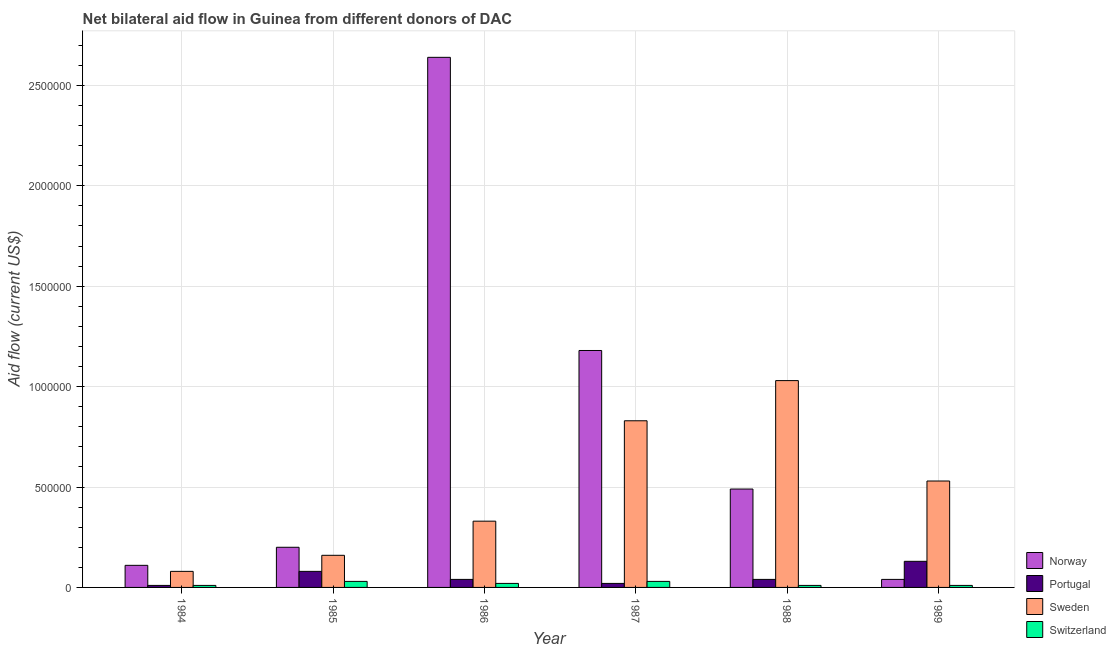How many groups of bars are there?
Your response must be concise. 6. Are the number of bars per tick equal to the number of legend labels?
Your answer should be compact. Yes. Are the number of bars on each tick of the X-axis equal?
Your response must be concise. Yes. How many bars are there on the 6th tick from the right?
Provide a short and direct response. 4. What is the label of the 1st group of bars from the left?
Make the answer very short. 1984. In how many cases, is the number of bars for a given year not equal to the number of legend labels?
Keep it short and to the point. 0. What is the amount of aid given by norway in 1984?
Your answer should be compact. 1.10e+05. Across all years, what is the maximum amount of aid given by portugal?
Make the answer very short. 1.30e+05. Across all years, what is the minimum amount of aid given by sweden?
Provide a short and direct response. 8.00e+04. What is the total amount of aid given by portugal in the graph?
Provide a short and direct response. 3.20e+05. What is the difference between the amount of aid given by sweden in 1985 and that in 1988?
Provide a short and direct response. -8.70e+05. What is the difference between the amount of aid given by portugal in 1984 and the amount of aid given by norway in 1987?
Offer a very short reply. -10000. What is the average amount of aid given by norway per year?
Your answer should be very brief. 7.77e+05. In the year 1988, what is the difference between the amount of aid given by switzerland and amount of aid given by sweden?
Keep it short and to the point. 0. What is the ratio of the amount of aid given by norway in 1984 to that in 1989?
Provide a short and direct response. 2.75. What is the difference between the highest and the second highest amount of aid given by norway?
Make the answer very short. 1.46e+06. What is the difference between the highest and the lowest amount of aid given by switzerland?
Your answer should be compact. 2.00e+04. What does the 3rd bar from the left in 1988 represents?
Make the answer very short. Sweden. What does the 2nd bar from the right in 1984 represents?
Your answer should be compact. Sweden. How many years are there in the graph?
Your answer should be very brief. 6. What is the difference between two consecutive major ticks on the Y-axis?
Your answer should be compact. 5.00e+05. Are the values on the major ticks of Y-axis written in scientific E-notation?
Offer a very short reply. No. Does the graph contain any zero values?
Your response must be concise. No. How many legend labels are there?
Offer a terse response. 4. How are the legend labels stacked?
Your answer should be compact. Vertical. What is the title of the graph?
Your answer should be very brief. Net bilateral aid flow in Guinea from different donors of DAC. What is the label or title of the X-axis?
Make the answer very short. Year. What is the Aid flow (current US$) of Norway in 1984?
Provide a succinct answer. 1.10e+05. What is the Aid flow (current US$) in Norway in 1985?
Make the answer very short. 2.00e+05. What is the Aid flow (current US$) in Switzerland in 1985?
Keep it short and to the point. 3.00e+04. What is the Aid flow (current US$) in Norway in 1986?
Provide a succinct answer. 2.64e+06. What is the Aid flow (current US$) in Portugal in 1986?
Give a very brief answer. 4.00e+04. What is the Aid flow (current US$) in Switzerland in 1986?
Make the answer very short. 2.00e+04. What is the Aid flow (current US$) of Norway in 1987?
Ensure brevity in your answer.  1.18e+06. What is the Aid flow (current US$) of Sweden in 1987?
Your response must be concise. 8.30e+05. What is the Aid flow (current US$) of Norway in 1988?
Provide a short and direct response. 4.90e+05. What is the Aid flow (current US$) of Portugal in 1988?
Make the answer very short. 4.00e+04. What is the Aid flow (current US$) in Sweden in 1988?
Make the answer very short. 1.03e+06. What is the Aid flow (current US$) in Sweden in 1989?
Your answer should be compact. 5.30e+05. Across all years, what is the maximum Aid flow (current US$) in Norway?
Offer a terse response. 2.64e+06. Across all years, what is the maximum Aid flow (current US$) in Sweden?
Your response must be concise. 1.03e+06. What is the total Aid flow (current US$) in Norway in the graph?
Offer a terse response. 4.66e+06. What is the total Aid flow (current US$) in Portugal in the graph?
Offer a very short reply. 3.20e+05. What is the total Aid flow (current US$) in Sweden in the graph?
Give a very brief answer. 2.96e+06. What is the difference between the Aid flow (current US$) in Portugal in 1984 and that in 1985?
Provide a succinct answer. -7.00e+04. What is the difference between the Aid flow (current US$) in Sweden in 1984 and that in 1985?
Make the answer very short. -8.00e+04. What is the difference between the Aid flow (current US$) in Switzerland in 1984 and that in 1985?
Make the answer very short. -2.00e+04. What is the difference between the Aid flow (current US$) in Norway in 1984 and that in 1986?
Make the answer very short. -2.53e+06. What is the difference between the Aid flow (current US$) in Portugal in 1984 and that in 1986?
Give a very brief answer. -3.00e+04. What is the difference between the Aid flow (current US$) of Norway in 1984 and that in 1987?
Keep it short and to the point. -1.07e+06. What is the difference between the Aid flow (current US$) in Portugal in 1984 and that in 1987?
Your answer should be very brief. -10000. What is the difference between the Aid flow (current US$) in Sweden in 1984 and that in 1987?
Offer a very short reply. -7.50e+05. What is the difference between the Aid flow (current US$) of Switzerland in 1984 and that in 1987?
Provide a succinct answer. -2.00e+04. What is the difference between the Aid flow (current US$) of Norway in 1984 and that in 1988?
Provide a short and direct response. -3.80e+05. What is the difference between the Aid flow (current US$) in Sweden in 1984 and that in 1988?
Your answer should be very brief. -9.50e+05. What is the difference between the Aid flow (current US$) of Portugal in 1984 and that in 1989?
Make the answer very short. -1.20e+05. What is the difference between the Aid flow (current US$) in Sweden in 1984 and that in 1989?
Offer a very short reply. -4.50e+05. What is the difference between the Aid flow (current US$) of Switzerland in 1984 and that in 1989?
Your answer should be compact. 0. What is the difference between the Aid flow (current US$) of Norway in 1985 and that in 1986?
Make the answer very short. -2.44e+06. What is the difference between the Aid flow (current US$) in Sweden in 1985 and that in 1986?
Give a very brief answer. -1.70e+05. What is the difference between the Aid flow (current US$) in Norway in 1985 and that in 1987?
Your answer should be very brief. -9.80e+05. What is the difference between the Aid flow (current US$) in Portugal in 1985 and that in 1987?
Your response must be concise. 6.00e+04. What is the difference between the Aid flow (current US$) of Sweden in 1985 and that in 1987?
Make the answer very short. -6.70e+05. What is the difference between the Aid flow (current US$) in Portugal in 1985 and that in 1988?
Provide a short and direct response. 4.00e+04. What is the difference between the Aid flow (current US$) of Sweden in 1985 and that in 1988?
Your answer should be compact. -8.70e+05. What is the difference between the Aid flow (current US$) in Norway in 1985 and that in 1989?
Provide a succinct answer. 1.60e+05. What is the difference between the Aid flow (current US$) of Portugal in 1985 and that in 1989?
Offer a very short reply. -5.00e+04. What is the difference between the Aid flow (current US$) in Sweden in 1985 and that in 1989?
Provide a short and direct response. -3.70e+05. What is the difference between the Aid flow (current US$) in Norway in 1986 and that in 1987?
Offer a terse response. 1.46e+06. What is the difference between the Aid flow (current US$) of Sweden in 1986 and that in 1987?
Give a very brief answer. -5.00e+05. What is the difference between the Aid flow (current US$) in Norway in 1986 and that in 1988?
Your answer should be compact. 2.15e+06. What is the difference between the Aid flow (current US$) of Sweden in 1986 and that in 1988?
Your answer should be very brief. -7.00e+05. What is the difference between the Aid flow (current US$) in Switzerland in 1986 and that in 1988?
Your answer should be compact. 10000. What is the difference between the Aid flow (current US$) in Norway in 1986 and that in 1989?
Offer a very short reply. 2.60e+06. What is the difference between the Aid flow (current US$) of Portugal in 1986 and that in 1989?
Give a very brief answer. -9.00e+04. What is the difference between the Aid flow (current US$) in Sweden in 1986 and that in 1989?
Your answer should be very brief. -2.00e+05. What is the difference between the Aid flow (current US$) in Switzerland in 1986 and that in 1989?
Your answer should be compact. 10000. What is the difference between the Aid flow (current US$) in Norway in 1987 and that in 1988?
Offer a terse response. 6.90e+05. What is the difference between the Aid flow (current US$) in Portugal in 1987 and that in 1988?
Your answer should be compact. -2.00e+04. What is the difference between the Aid flow (current US$) in Norway in 1987 and that in 1989?
Provide a succinct answer. 1.14e+06. What is the difference between the Aid flow (current US$) of Sweden in 1988 and that in 1989?
Ensure brevity in your answer.  5.00e+05. What is the difference between the Aid flow (current US$) of Norway in 1984 and the Aid flow (current US$) of Portugal in 1985?
Your response must be concise. 3.00e+04. What is the difference between the Aid flow (current US$) of Norway in 1984 and the Aid flow (current US$) of Sweden in 1985?
Provide a short and direct response. -5.00e+04. What is the difference between the Aid flow (current US$) of Portugal in 1984 and the Aid flow (current US$) of Sweden in 1985?
Provide a succinct answer. -1.50e+05. What is the difference between the Aid flow (current US$) in Norway in 1984 and the Aid flow (current US$) in Portugal in 1986?
Your response must be concise. 7.00e+04. What is the difference between the Aid flow (current US$) of Norway in 1984 and the Aid flow (current US$) of Sweden in 1986?
Provide a succinct answer. -2.20e+05. What is the difference between the Aid flow (current US$) of Portugal in 1984 and the Aid flow (current US$) of Sweden in 1986?
Your response must be concise. -3.20e+05. What is the difference between the Aid flow (current US$) of Portugal in 1984 and the Aid flow (current US$) of Switzerland in 1986?
Make the answer very short. -10000. What is the difference between the Aid flow (current US$) in Norway in 1984 and the Aid flow (current US$) in Sweden in 1987?
Provide a short and direct response. -7.20e+05. What is the difference between the Aid flow (current US$) of Norway in 1984 and the Aid flow (current US$) of Switzerland in 1987?
Your answer should be compact. 8.00e+04. What is the difference between the Aid flow (current US$) of Portugal in 1984 and the Aid flow (current US$) of Sweden in 1987?
Ensure brevity in your answer.  -8.20e+05. What is the difference between the Aid flow (current US$) in Sweden in 1984 and the Aid flow (current US$) in Switzerland in 1987?
Provide a succinct answer. 5.00e+04. What is the difference between the Aid flow (current US$) of Norway in 1984 and the Aid flow (current US$) of Portugal in 1988?
Give a very brief answer. 7.00e+04. What is the difference between the Aid flow (current US$) in Norway in 1984 and the Aid flow (current US$) in Sweden in 1988?
Ensure brevity in your answer.  -9.20e+05. What is the difference between the Aid flow (current US$) of Portugal in 1984 and the Aid flow (current US$) of Sweden in 1988?
Offer a terse response. -1.02e+06. What is the difference between the Aid flow (current US$) in Sweden in 1984 and the Aid flow (current US$) in Switzerland in 1988?
Provide a short and direct response. 7.00e+04. What is the difference between the Aid flow (current US$) in Norway in 1984 and the Aid flow (current US$) in Portugal in 1989?
Offer a terse response. -2.00e+04. What is the difference between the Aid flow (current US$) in Norway in 1984 and the Aid flow (current US$) in Sweden in 1989?
Your answer should be very brief. -4.20e+05. What is the difference between the Aid flow (current US$) of Norway in 1984 and the Aid flow (current US$) of Switzerland in 1989?
Offer a very short reply. 1.00e+05. What is the difference between the Aid flow (current US$) in Portugal in 1984 and the Aid flow (current US$) in Sweden in 1989?
Your answer should be very brief. -5.20e+05. What is the difference between the Aid flow (current US$) of Portugal in 1984 and the Aid flow (current US$) of Switzerland in 1989?
Your response must be concise. 0. What is the difference between the Aid flow (current US$) in Norway in 1985 and the Aid flow (current US$) in Sweden in 1986?
Provide a succinct answer. -1.30e+05. What is the difference between the Aid flow (current US$) in Portugal in 1985 and the Aid flow (current US$) in Sweden in 1986?
Ensure brevity in your answer.  -2.50e+05. What is the difference between the Aid flow (current US$) of Norway in 1985 and the Aid flow (current US$) of Portugal in 1987?
Give a very brief answer. 1.80e+05. What is the difference between the Aid flow (current US$) of Norway in 1985 and the Aid flow (current US$) of Sweden in 1987?
Ensure brevity in your answer.  -6.30e+05. What is the difference between the Aid flow (current US$) in Norway in 1985 and the Aid flow (current US$) in Switzerland in 1987?
Keep it short and to the point. 1.70e+05. What is the difference between the Aid flow (current US$) in Portugal in 1985 and the Aid flow (current US$) in Sweden in 1987?
Give a very brief answer. -7.50e+05. What is the difference between the Aid flow (current US$) of Sweden in 1985 and the Aid flow (current US$) of Switzerland in 1987?
Your answer should be very brief. 1.30e+05. What is the difference between the Aid flow (current US$) of Norway in 1985 and the Aid flow (current US$) of Sweden in 1988?
Give a very brief answer. -8.30e+05. What is the difference between the Aid flow (current US$) of Norway in 1985 and the Aid flow (current US$) of Switzerland in 1988?
Ensure brevity in your answer.  1.90e+05. What is the difference between the Aid flow (current US$) in Portugal in 1985 and the Aid flow (current US$) in Sweden in 1988?
Provide a succinct answer. -9.50e+05. What is the difference between the Aid flow (current US$) of Sweden in 1985 and the Aid flow (current US$) of Switzerland in 1988?
Your response must be concise. 1.50e+05. What is the difference between the Aid flow (current US$) in Norway in 1985 and the Aid flow (current US$) in Portugal in 1989?
Your response must be concise. 7.00e+04. What is the difference between the Aid flow (current US$) of Norway in 1985 and the Aid flow (current US$) of Sweden in 1989?
Your response must be concise. -3.30e+05. What is the difference between the Aid flow (current US$) in Norway in 1985 and the Aid flow (current US$) in Switzerland in 1989?
Your response must be concise. 1.90e+05. What is the difference between the Aid flow (current US$) of Portugal in 1985 and the Aid flow (current US$) of Sweden in 1989?
Offer a terse response. -4.50e+05. What is the difference between the Aid flow (current US$) of Norway in 1986 and the Aid flow (current US$) of Portugal in 1987?
Provide a short and direct response. 2.62e+06. What is the difference between the Aid flow (current US$) of Norway in 1986 and the Aid flow (current US$) of Sweden in 1987?
Keep it short and to the point. 1.81e+06. What is the difference between the Aid flow (current US$) in Norway in 1986 and the Aid flow (current US$) in Switzerland in 1987?
Ensure brevity in your answer.  2.61e+06. What is the difference between the Aid flow (current US$) in Portugal in 1986 and the Aid flow (current US$) in Sweden in 1987?
Your answer should be compact. -7.90e+05. What is the difference between the Aid flow (current US$) of Portugal in 1986 and the Aid flow (current US$) of Switzerland in 1987?
Your answer should be very brief. 10000. What is the difference between the Aid flow (current US$) in Norway in 1986 and the Aid flow (current US$) in Portugal in 1988?
Your answer should be compact. 2.60e+06. What is the difference between the Aid flow (current US$) in Norway in 1986 and the Aid flow (current US$) in Sweden in 1988?
Offer a terse response. 1.61e+06. What is the difference between the Aid flow (current US$) in Norway in 1986 and the Aid flow (current US$) in Switzerland in 1988?
Your response must be concise. 2.63e+06. What is the difference between the Aid flow (current US$) in Portugal in 1986 and the Aid flow (current US$) in Sweden in 1988?
Your response must be concise. -9.90e+05. What is the difference between the Aid flow (current US$) in Portugal in 1986 and the Aid flow (current US$) in Switzerland in 1988?
Your answer should be very brief. 3.00e+04. What is the difference between the Aid flow (current US$) of Sweden in 1986 and the Aid flow (current US$) of Switzerland in 1988?
Offer a terse response. 3.20e+05. What is the difference between the Aid flow (current US$) of Norway in 1986 and the Aid flow (current US$) of Portugal in 1989?
Make the answer very short. 2.51e+06. What is the difference between the Aid flow (current US$) in Norway in 1986 and the Aid flow (current US$) in Sweden in 1989?
Provide a short and direct response. 2.11e+06. What is the difference between the Aid flow (current US$) of Norway in 1986 and the Aid flow (current US$) of Switzerland in 1989?
Offer a very short reply. 2.63e+06. What is the difference between the Aid flow (current US$) of Portugal in 1986 and the Aid flow (current US$) of Sweden in 1989?
Your answer should be very brief. -4.90e+05. What is the difference between the Aid flow (current US$) of Portugal in 1986 and the Aid flow (current US$) of Switzerland in 1989?
Your response must be concise. 3.00e+04. What is the difference between the Aid flow (current US$) in Norway in 1987 and the Aid flow (current US$) in Portugal in 1988?
Your answer should be very brief. 1.14e+06. What is the difference between the Aid flow (current US$) of Norway in 1987 and the Aid flow (current US$) of Sweden in 1988?
Offer a terse response. 1.50e+05. What is the difference between the Aid flow (current US$) of Norway in 1987 and the Aid flow (current US$) of Switzerland in 1988?
Keep it short and to the point. 1.17e+06. What is the difference between the Aid flow (current US$) in Portugal in 1987 and the Aid flow (current US$) in Sweden in 1988?
Give a very brief answer. -1.01e+06. What is the difference between the Aid flow (current US$) of Sweden in 1987 and the Aid flow (current US$) of Switzerland in 1988?
Your response must be concise. 8.20e+05. What is the difference between the Aid flow (current US$) of Norway in 1987 and the Aid flow (current US$) of Portugal in 1989?
Ensure brevity in your answer.  1.05e+06. What is the difference between the Aid flow (current US$) of Norway in 1987 and the Aid flow (current US$) of Sweden in 1989?
Ensure brevity in your answer.  6.50e+05. What is the difference between the Aid flow (current US$) in Norway in 1987 and the Aid flow (current US$) in Switzerland in 1989?
Your answer should be very brief. 1.17e+06. What is the difference between the Aid flow (current US$) in Portugal in 1987 and the Aid flow (current US$) in Sweden in 1989?
Provide a succinct answer. -5.10e+05. What is the difference between the Aid flow (current US$) in Portugal in 1987 and the Aid flow (current US$) in Switzerland in 1989?
Provide a short and direct response. 10000. What is the difference between the Aid flow (current US$) in Sweden in 1987 and the Aid flow (current US$) in Switzerland in 1989?
Give a very brief answer. 8.20e+05. What is the difference between the Aid flow (current US$) in Norway in 1988 and the Aid flow (current US$) in Sweden in 1989?
Offer a very short reply. -4.00e+04. What is the difference between the Aid flow (current US$) in Portugal in 1988 and the Aid flow (current US$) in Sweden in 1989?
Your response must be concise. -4.90e+05. What is the difference between the Aid flow (current US$) of Portugal in 1988 and the Aid flow (current US$) of Switzerland in 1989?
Your answer should be compact. 3.00e+04. What is the difference between the Aid flow (current US$) in Sweden in 1988 and the Aid flow (current US$) in Switzerland in 1989?
Ensure brevity in your answer.  1.02e+06. What is the average Aid flow (current US$) of Norway per year?
Your answer should be compact. 7.77e+05. What is the average Aid flow (current US$) in Portugal per year?
Offer a very short reply. 5.33e+04. What is the average Aid flow (current US$) of Sweden per year?
Ensure brevity in your answer.  4.93e+05. What is the average Aid flow (current US$) of Switzerland per year?
Offer a very short reply. 1.83e+04. In the year 1984, what is the difference between the Aid flow (current US$) in Norway and Aid flow (current US$) in Sweden?
Provide a succinct answer. 3.00e+04. In the year 1984, what is the difference between the Aid flow (current US$) in Norway and Aid flow (current US$) in Switzerland?
Your response must be concise. 1.00e+05. In the year 1984, what is the difference between the Aid flow (current US$) in Portugal and Aid flow (current US$) in Switzerland?
Your response must be concise. 0. In the year 1984, what is the difference between the Aid flow (current US$) of Sweden and Aid flow (current US$) of Switzerland?
Your response must be concise. 7.00e+04. In the year 1986, what is the difference between the Aid flow (current US$) in Norway and Aid flow (current US$) in Portugal?
Your answer should be very brief. 2.60e+06. In the year 1986, what is the difference between the Aid flow (current US$) in Norway and Aid flow (current US$) in Sweden?
Your answer should be very brief. 2.31e+06. In the year 1986, what is the difference between the Aid flow (current US$) in Norway and Aid flow (current US$) in Switzerland?
Make the answer very short. 2.62e+06. In the year 1987, what is the difference between the Aid flow (current US$) of Norway and Aid flow (current US$) of Portugal?
Your answer should be very brief. 1.16e+06. In the year 1987, what is the difference between the Aid flow (current US$) in Norway and Aid flow (current US$) in Sweden?
Offer a very short reply. 3.50e+05. In the year 1987, what is the difference between the Aid flow (current US$) in Norway and Aid flow (current US$) in Switzerland?
Make the answer very short. 1.15e+06. In the year 1987, what is the difference between the Aid flow (current US$) of Portugal and Aid flow (current US$) of Sweden?
Make the answer very short. -8.10e+05. In the year 1987, what is the difference between the Aid flow (current US$) of Portugal and Aid flow (current US$) of Switzerland?
Offer a terse response. -10000. In the year 1988, what is the difference between the Aid flow (current US$) of Norway and Aid flow (current US$) of Sweden?
Keep it short and to the point. -5.40e+05. In the year 1988, what is the difference between the Aid flow (current US$) of Norway and Aid flow (current US$) of Switzerland?
Your response must be concise. 4.80e+05. In the year 1988, what is the difference between the Aid flow (current US$) in Portugal and Aid flow (current US$) in Sweden?
Your answer should be compact. -9.90e+05. In the year 1988, what is the difference between the Aid flow (current US$) in Sweden and Aid flow (current US$) in Switzerland?
Provide a short and direct response. 1.02e+06. In the year 1989, what is the difference between the Aid flow (current US$) of Norway and Aid flow (current US$) of Sweden?
Keep it short and to the point. -4.90e+05. In the year 1989, what is the difference between the Aid flow (current US$) of Portugal and Aid flow (current US$) of Sweden?
Offer a terse response. -4.00e+05. In the year 1989, what is the difference between the Aid flow (current US$) in Portugal and Aid flow (current US$) in Switzerland?
Offer a terse response. 1.20e+05. In the year 1989, what is the difference between the Aid flow (current US$) of Sweden and Aid flow (current US$) of Switzerland?
Your answer should be compact. 5.20e+05. What is the ratio of the Aid flow (current US$) of Norway in 1984 to that in 1985?
Your answer should be compact. 0.55. What is the ratio of the Aid flow (current US$) of Portugal in 1984 to that in 1985?
Your response must be concise. 0.12. What is the ratio of the Aid flow (current US$) of Switzerland in 1984 to that in 1985?
Ensure brevity in your answer.  0.33. What is the ratio of the Aid flow (current US$) in Norway in 1984 to that in 1986?
Provide a short and direct response. 0.04. What is the ratio of the Aid flow (current US$) in Portugal in 1984 to that in 1986?
Provide a succinct answer. 0.25. What is the ratio of the Aid flow (current US$) of Sweden in 1984 to that in 1986?
Offer a very short reply. 0.24. What is the ratio of the Aid flow (current US$) in Norway in 1984 to that in 1987?
Make the answer very short. 0.09. What is the ratio of the Aid flow (current US$) in Portugal in 1984 to that in 1987?
Give a very brief answer. 0.5. What is the ratio of the Aid flow (current US$) of Sweden in 1984 to that in 1987?
Keep it short and to the point. 0.1. What is the ratio of the Aid flow (current US$) of Switzerland in 1984 to that in 1987?
Your answer should be compact. 0.33. What is the ratio of the Aid flow (current US$) in Norway in 1984 to that in 1988?
Your answer should be compact. 0.22. What is the ratio of the Aid flow (current US$) of Sweden in 1984 to that in 1988?
Your response must be concise. 0.08. What is the ratio of the Aid flow (current US$) of Norway in 1984 to that in 1989?
Your response must be concise. 2.75. What is the ratio of the Aid flow (current US$) of Portugal in 1984 to that in 1989?
Provide a succinct answer. 0.08. What is the ratio of the Aid flow (current US$) of Sweden in 1984 to that in 1989?
Make the answer very short. 0.15. What is the ratio of the Aid flow (current US$) of Norway in 1985 to that in 1986?
Your answer should be compact. 0.08. What is the ratio of the Aid flow (current US$) in Sweden in 1985 to that in 1986?
Your answer should be very brief. 0.48. What is the ratio of the Aid flow (current US$) of Switzerland in 1985 to that in 1986?
Your response must be concise. 1.5. What is the ratio of the Aid flow (current US$) in Norway in 1985 to that in 1987?
Your answer should be compact. 0.17. What is the ratio of the Aid flow (current US$) in Sweden in 1985 to that in 1987?
Your response must be concise. 0.19. What is the ratio of the Aid flow (current US$) in Switzerland in 1985 to that in 1987?
Ensure brevity in your answer.  1. What is the ratio of the Aid flow (current US$) of Norway in 1985 to that in 1988?
Make the answer very short. 0.41. What is the ratio of the Aid flow (current US$) in Portugal in 1985 to that in 1988?
Your answer should be compact. 2. What is the ratio of the Aid flow (current US$) in Sweden in 1985 to that in 1988?
Ensure brevity in your answer.  0.16. What is the ratio of the Aid flow (current US$) in Switzerland in 1985 to that in 1988?
Give a very brief answer. 3. What is the ratio of the Aid flow (current US$) in Portugal in 1985 to that in 1989?
Your answer should be very brief. 0.62. What is the ratio of the Aid flow (current US$) in Sweden in 1985 to that in 1989?
Provide a succinct answer. 0.3. What is the ratio of the Aid flow (current US$) of Switzerland in 1985 to that in 1989?
Make the answer very short. 3. What is the ratio of the Aid flow (current US$) in Norway in 1986 to that in 1987?
Your answer should be very brief. 2.24. What is the ratio of the Aid flow (current US$) of Sweden in 1986 to that in 1987?
Provide a short and direct response. 0.4. What is the ratio of the Aid flow (current US$) in Switzerland in 1986 to that in 1987?
Your response must be concise. 0.67. What is the ratio of the Aid flow (current US$) of Norway in 1986 to that in 1988?
Offer a very short reply. 5.39. What is the ratio of the Aid flow (current US$) in Sweden in 1986 to that in 1988?
Your response must be concise. 0.32. What is the ratio of the Aid flow (current US$) in Switzerland in 1986 to that in 1988?
Ensure brevity in your answer.  2. What is the ratio of the Aid flow (current US$) of Portugal in 1986 to that in 1989?
Provide a short and direct response. 0.31. What is the ratio of the Aid flow (current US$) of Sweden in 1986 to that in 1989?
Offer a terse response. 0.62. What is the ratio of the Aid flow (current US$) of Norway in 1987 to that in 1988?
Make the answer very short. 2.41. What is the ratio of the Aid flow (current US$) of Sweden in 1987 to that in 1988?
Provide a short and direct response. 0.81. What is the ratio of the Aid flow (current US$) in Norway in 1987 to that in 1989?
Your response must be concise. 29.5. What is the ratio of the Aid flow (current US$) in Portugal in 1987 to that in 1989?
Provide a succinct answer. 0.15. What is the ratio of the Aid flow (current US$) of Sweden in 1987 to that in 1989?
Your response must be concise. 1.57. What is the ratio of the Aid flow (current US$) in Norway in 1988 to that in 1989?
Offer a very short reply. 12.25. What is the ratio of the Aid flow (current US$) of Portugal in 1988 to that in 1989?
Provide a short and direct response. 0.31. What is the ratio of the Aid flow (current US$) of Sweden in 1988 to that in 1989?
Offer a terse response. 1.94. What is the difference between the highest and the second highest Aid flow (current US$) of Norway?
Keep it short and to the point. 1.46e+06. What is the difference between the highest and the lowest Aid flow (current US$) of Norway?
Give a very brief answer. 2.60e+06. What is the difference between the highest and the lowest Aid flow (current US$) of Portugal?
Your answer should be compact. 1.20e+05. What is the difference between the highest and the lowest Aid flow (current US$) in Sweden?
Offer a terse response. 9.50e+05. 